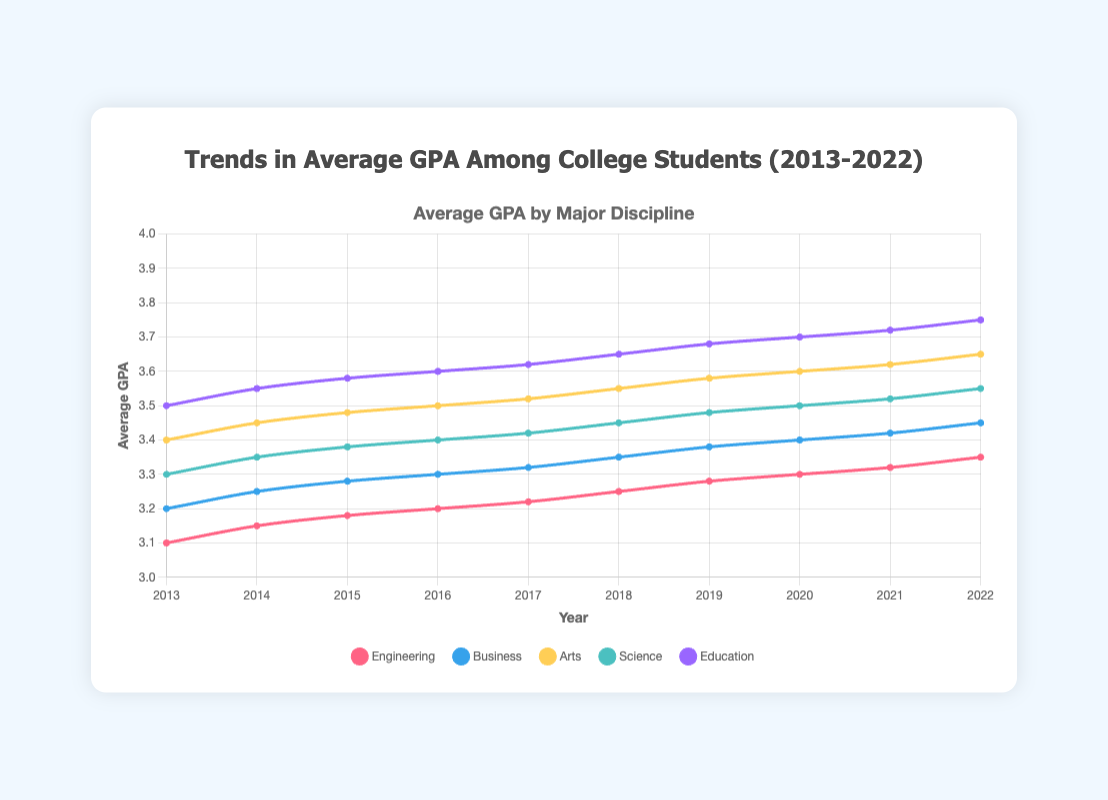What is the overall trend in average GPA for the Engineering discipline from 2013 to 2022? The visual line for Engineering shows a consistent upward trend from 3.1 in 2013 to 3.35 in 2022, indicating a gradual increase in average GPA over the decade.
Answer: Upward trend Which major had the highest average GPA in 2022? In 2022, the highest average GPA is denoted by the tallest line on the y-axis, which corresponds to Education with a GPA of 3.75.
Answer: Education Compare the trends for Business and Arts. Which one had a steeper increase in their GPA over the decade? From 2013 to 2022, Business increased from 3.2 to 3.45 (0.25 increase), while Arts increased from 3.4 to 3.65 (0.25 increase). Both had the same increase, but visually Arts seems to have a slightly steeper slope in certain years.
Answer: Equal Which two majors had the closest average GPAs in 2016, and what were they? In 2016, Engineering and Science had GPAs of 3.2 and 3.4 respectively, the smallest visual distance between their lines.
Answer: Engineering and Science What is the average GPA difference between Education and Engineering in 2022? In 2022, the Education GPA is 3.75 and the Engineering GPA is 3.35. The difference is calculated as 3.75 - 3.35 = 0.4.
Answer: 0.4 Identify the major with the most consistent GPA increase over the years. Visual analysis shows steady incremental increases in the line for Education, indicating the most consistent GPA increase from 2013 (3.5) to 2022 (3.75).
Answer: Education Which major had the least improvement in GPA over the decade? Engineering had the smallest increase from 3.1 in 2013 to 3.35 in 2022, indicating the least improvement.
Answer: Engineering In which year did Science first surpass an average GPA of 3.4? The line for Science surpasses 3.4 in the year 2017 when its GPA reached 3.42.
Answer: 2017 What is the cumulative increase in average GPA for the Arts major from 2013 to 2022? Arts GPA increases from 3.4 in 2013 to 3.65 in 2022. The cumulative increase is calculated as 3.65 - 3.4 = 0.25.
Answer: 0.25 